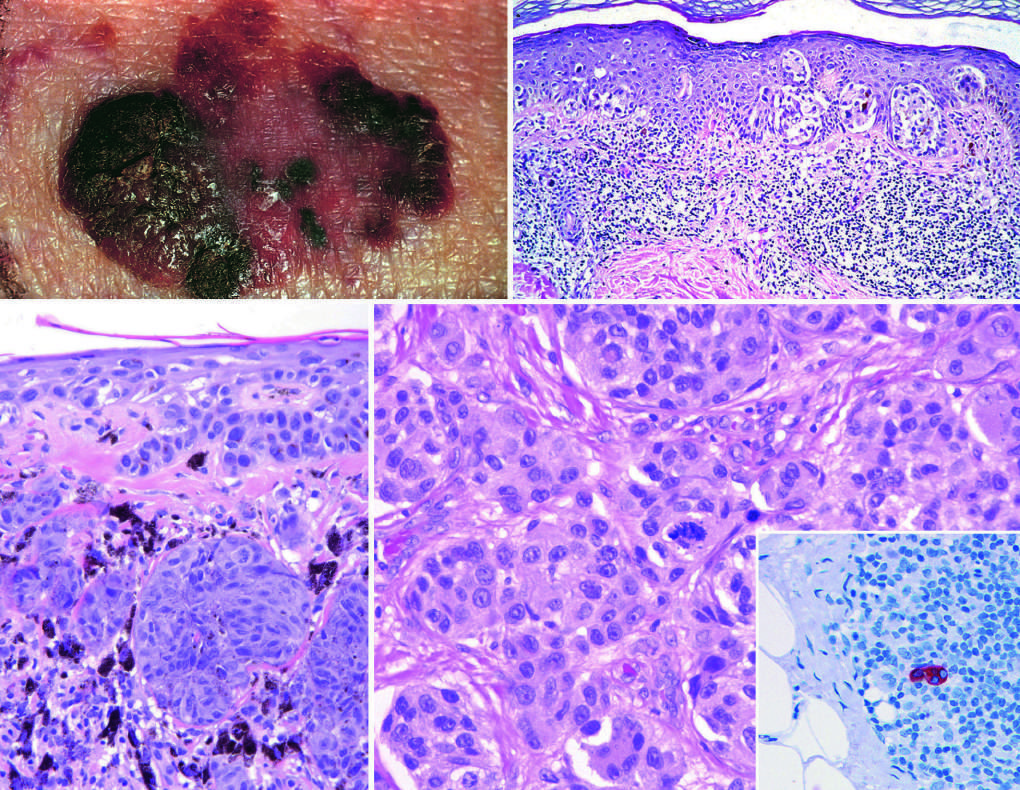do lesions tend to be larger than nevi, with irregular contours and variable pigmentation?
Answer the question using a single word or phrase. Yes 